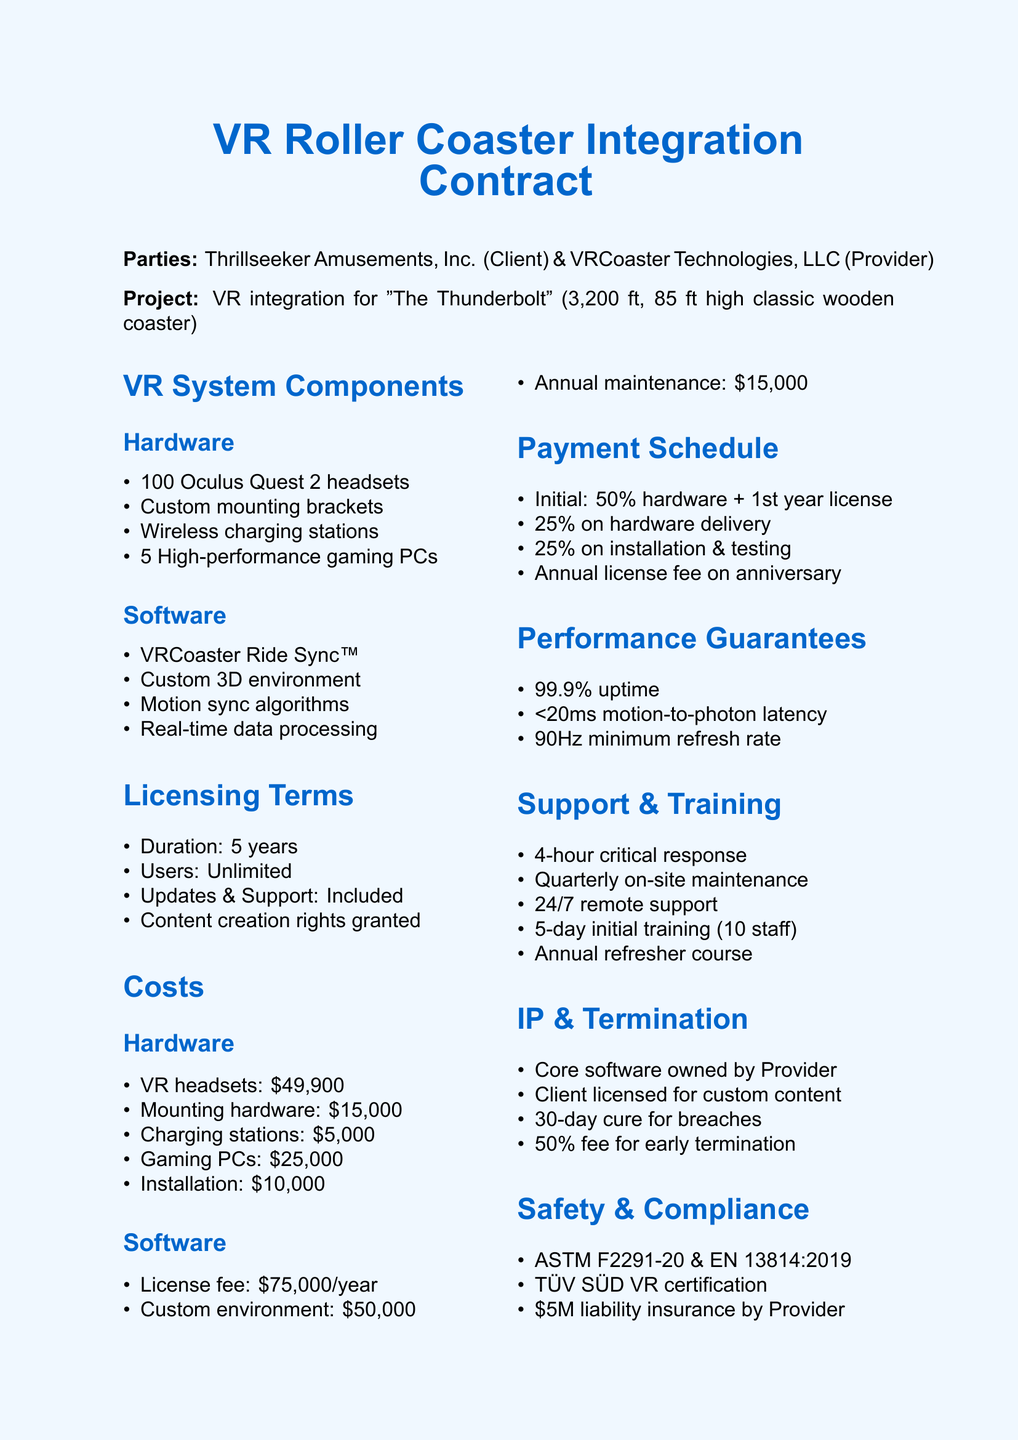What is the name of the coaster? The document specifies that the coaster is named "The Thunderbolt."
Answer: The Thunderbolt How many Oculus Quest 2 headsets are included? The document mentions that 100 Oculus Quest 2 headsets are part of the hardware components.
Answer: 100 units What is the license fee for the software per year? The document states that the license fee is "$75,000 per year."
Answer: $75,000 per year What is the initial payment percentage? According to the payment schedule, the initial payment is 50% of total hardware costs and the first year's software license.
Answer: 50% What is the guaranteed uptime? The document indicates a performance guarantee of "99.9% uptime during operating hours."
Answer: 99.9% What is the duration of the licensing terms? The document specifies that the licensing terms extend for a duration of "5 years."
Answer: 5 years What training is provided for staff? The document outlines "5-day on-site training for up to 10 staff members" as the initial training.
Answer: 5-day on-site training What is the early termination fee? The termination clause states the early termination fee is "50% of remaining contract value."
Answer: 50% What compliance standards are mentioned? The safety compliance section lists standards including "ASTM F2291-20 and EN 13814:2019."
Answer: ASTM F2291-20 and EN 13814:2019 